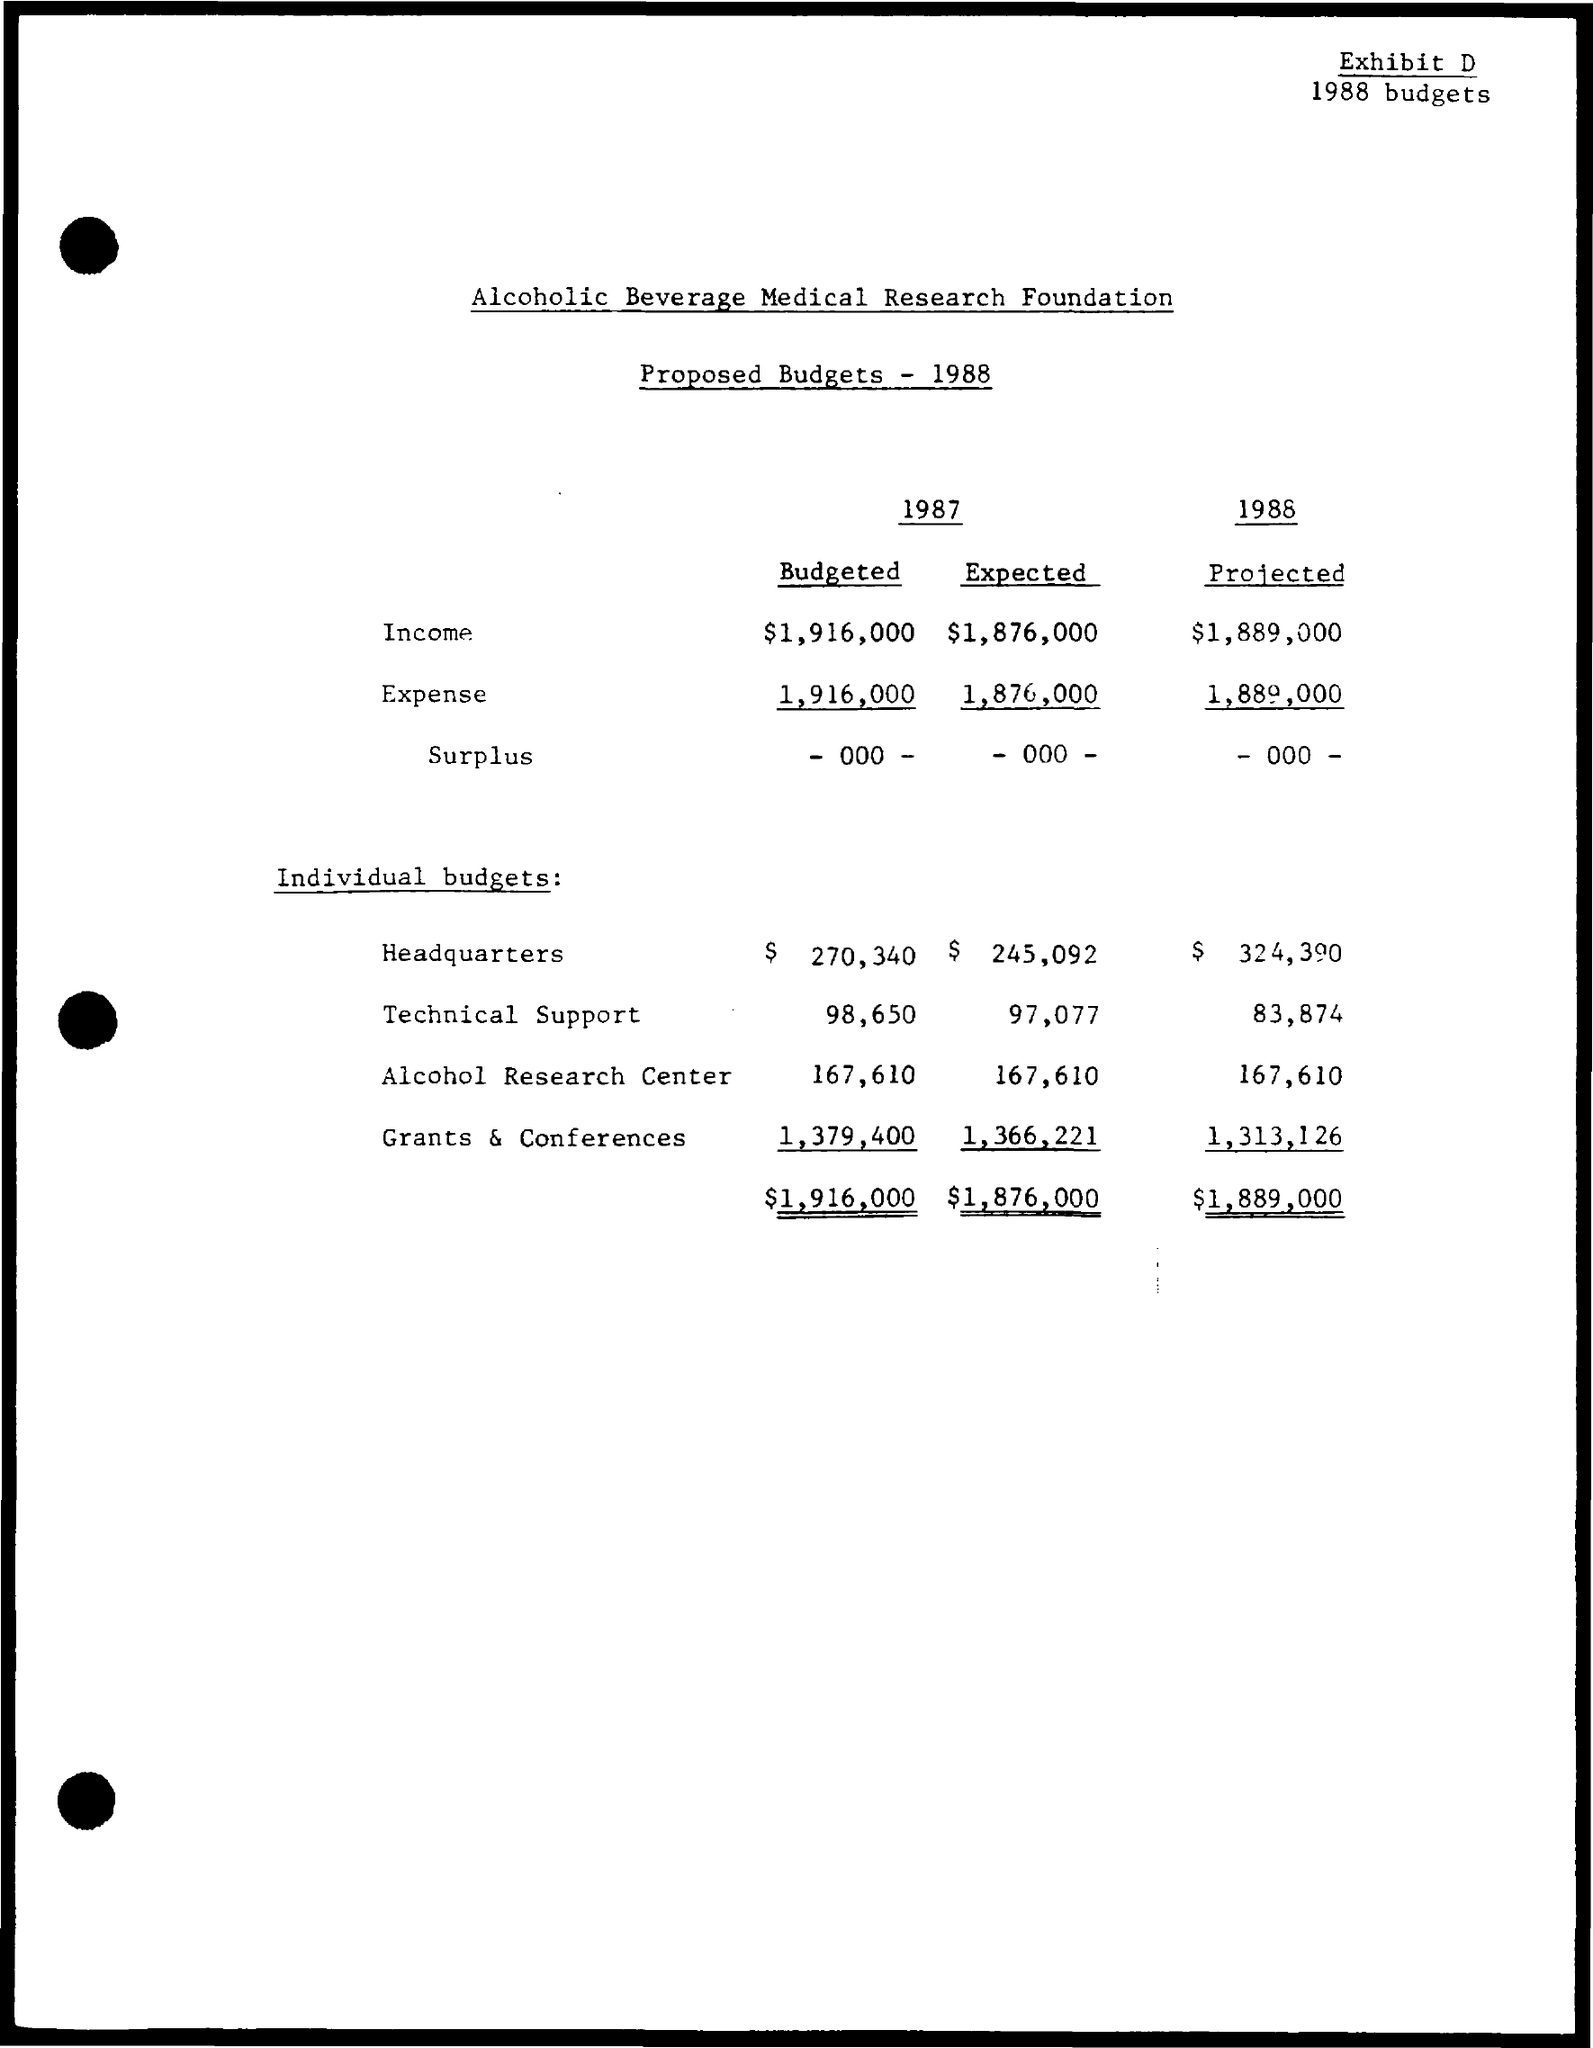Which company's Proposed Budget is given here?
Your answer should be compact. Alcoholic Beverage Medical Research Foundation. What is the budgeted income for the year 1987?
Provide a succinct answer. $1,916,000. What is the projected income for the year 1988?
Provide a succinct answer. $1,889,000. What is the budgeted expense for the year 1987?
Provide a short and direct response. 1,916,000. What is the projected budget for technical support in the year 1988?
Your response must be concise. 83,874. What is the Expected budget for Alcohol Research center for the year 1987?
Your answer should be compact. $ 167,610. 